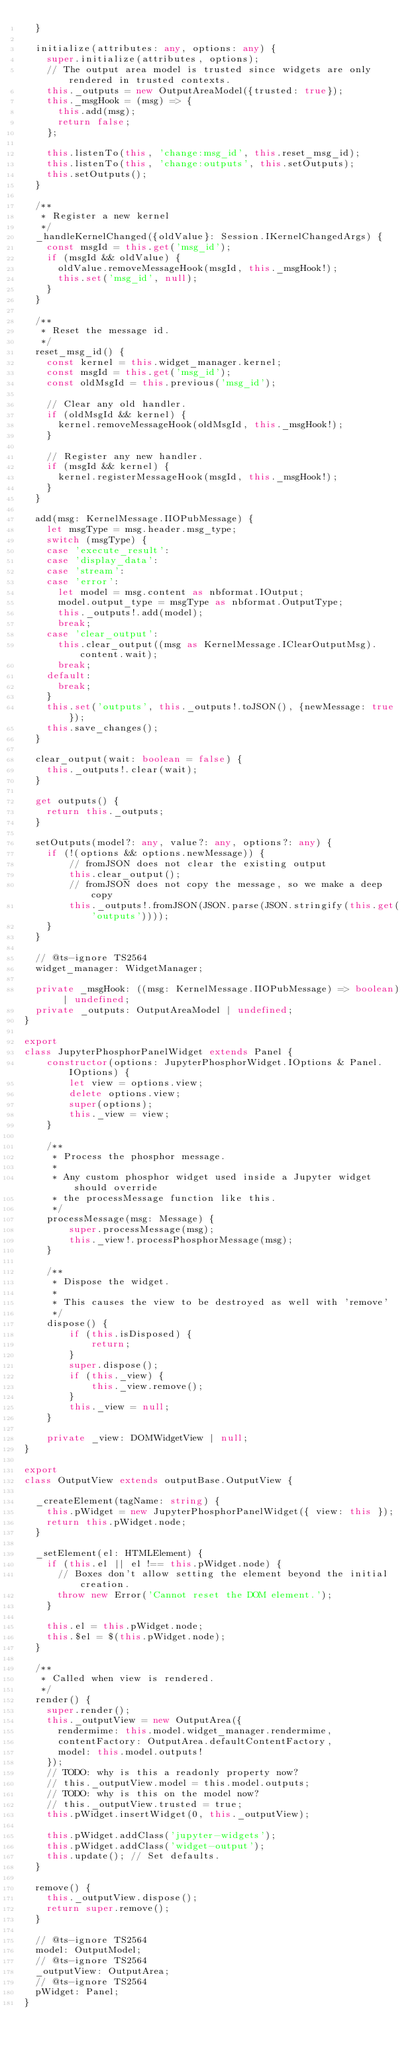Convert code to text. <code><loc_0><loc_0><loc_500><loc_500><_TypeScript_>  }

  initialize(attributes: any, options: any) {
    super.initialize(attributes, options);
    // The output area model is trusted since widgets are only rendered in trusted contexts.
    this._outputs = new OutputAreaModel({trusted: true});
    this._msgHook = (msg) => {
      this.add(msg);
      return false;
    };

    this.listenTo(this, 'change:msg_id', this.reset_msg_id);
    this.listenTo(this, 'change:outputs', this.setOutputs);
    this.setOutputs();
  }

  /**
   * Register a new kernel
   */
  _handleKernelChanged({oldValue}: Session.IKernelChangedArgs) {
    const msgId = this.get('msg_id');
    if (msgId && oldValue) {
      oldValue.removeMessageHook(msgId, this._msgHook!);
      this.set('msg_id', null);
    }
  }

  /**
   * Reset the message id.
   */
  reset_msg_id() {
    const kernel = this.widget_manager.kernel;
    const msgId = this.get('msg_id');
    const oldMsgId = this.previous('msg_id');

    // Clear any old handler.
    if (oldMsgId && kernel) {
      kernel.removeMessageHook(oldMsgId, this._msgHook!);
    }

    // Register any new handler.
    if (msgId && kernel) {
      kernel.registerMessageHook(msgId, this._msgHook!);
    }
  }

  add(msg: KernelMessage.IIOPubMessage) {
    let msgType = msg.header.msg_type;
    switch (msgType) {
    case 'execute_result':
    case 'display_data':
    case 'stream':
    case 'error':
      let model = msg.content as nbformat.IOutput;
      model.output_type = msgType as nbformat.OutputType;
      this._outputs!.add(model);
      break;
    case 'clear_output':
      this.clear_output((msg as KernelMessage.IClearOutputMsg).content.wait);
      break;
    default:
      break;
    }
    this.set('outputs', this._outputs!.toJSON(), {newMessage: true});
    this.save_changes();
  }

  clear_output(wait: boolean = false) {
    this._outputs!.clear(wait);
  }

  get outputs() {
    return this._outputs;
  }

  setOutputs(model?: any, value?: any, options?: any) {
    if (!(options && options.newMessage)) {
        // fromJSON does not clear the existing output
        this.clear_output();
        // fromJSON does not copy the message, so we make a deep copy
        this._outputs!.fromJSON(JSON.parse(JSON.stringify(this.get('outputs'))));
    }
  }

  // @ts-ignore TS2564
  widget_manager: WidgetManager;

  private _msgHook: ((msg: KernelMessage.IIOPubMessage) => boolean) | undefined;
  private _outputs: OutputAreaModel | undefined;
}

export
class JupyterPhosphorPanelWidget extends Panel {
    constructor(options: JupyterPhosphorWidget.IOptions & Panel.IOptions) {
        let view = options.view;
        delete options.view;
        super(options);
        this._view = view;
    }

    /**
     * Process the phosphor message.
     *
     * Any custom phosphor widget used inside a Jupyter widget should override
     * the processMessage function like this.
     */
    processMessage(msg: Message) {
        super.processMessage(msg);
        this._view!.processPhosphorMessage(msg);
    }

    /**
     * Dispose the widget.
     *
     * This causes the view to be destroyed as well with 'remove'
     */
    dispose() {
        if (this.isDisposed) {
            return;
        }
        super.dispose();
        if (this._view) {
            this._view.remove();
        }
        this._view = null;
    }

    private _view: DOMWidgetView | null;
}

export
class OutputView extends outputBase.OutputView {

  _createElement(tagName: string) {
    this.pWidget = new JupyterPhosphorPanelWidget({ view: this });
    return this.pWidget.node;
  }

  _setElement(el: HTMLElement) {
    if (this.el || el !== this.pWidget.node) {
      // Boxes don't allow setting the element beyond the initial creation.
      throw new Error('Cannot reset the DOM element.');
    }

    this.el = this.pWidget.node;
    this.$el = $(this.pWidget.node);
  }

  /**
   * Called when view is rendered.
   */
  render() {
    super.render();
    this._outputView = new OutputArea({
      rendermime: this.model.widget_manager.rendermime,
      contentFactory: OutputArea.defaultContentFactory,
      model: this.model.outputs!
    });
    // TODO: why is this a readonly property now?
    // this._outputView.model = this.model.outputs;
    // TODO: why is this on the model now?
    // this._outputView.trusted = true;
    this.pWidget.insertWidget(0, this._outputView);

    this.pWidget.addClass('jupyter-widgets');
    this.pWidget.addClass('widget-output');
    this.update(); // Set defaults.
  }

  remove() {
    this._outputView.dispose();
    return super.remove();
  }

  // @ts-ignore TS2564
  model: OutputModel;
  // @ts-ignore TS2564
  _outputView: OutputArea;
  // @ts-ignore TS2564
  pWidget: Panel;
}
</code> 